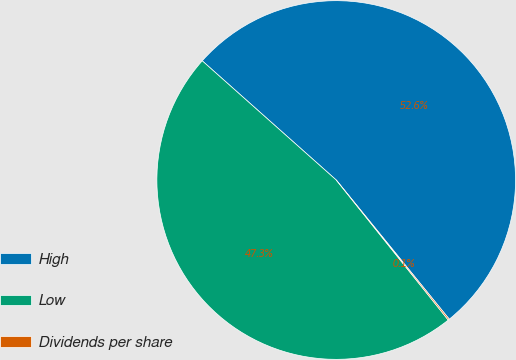<chart> <loc_0><loc_0><loc_500><loc_500><pie_chart><fcel>High<fcel>Low<fcel>Dividends per share<nl><fcel>52.57%<fcel>47.31%<fcel>0.12%<nl></chart> 